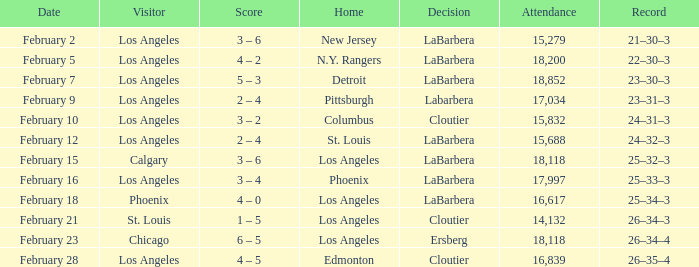What was the verdict of the kings contest when chicago was the visiting side? Ersberg. 